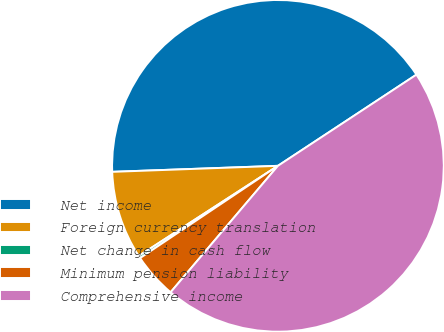<chart> <loc_0><loc_0><loc_500><loc_500><pie_chart><fcel>Net income<fcel>Foreign currency translation<fcel>Net change in cash flow<fcel>Minimum pension liability<fcel>Comprehensive income<nl><fcel>41.31%<fcel>8.57%<fcel>0.24%<fcel>4.41%<fcel>45.47%<nl></chart> 